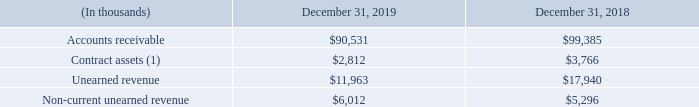Revenue allocated to remaining performance obligations represents contract revenues that have not yet been recognized for contracts with a duration greater than one year. As of December 31, 2019, we did not have any significant performance obligations related to customer contracts that had an original expected duration of one year or more, other than maintenance services, which are satisfied over time. As a practical expedient, for certain contracts recognize revenue equal to the amounts we are entitled to invoice which correspond to the value of completed performance obligations to date. The amount related to these performance obligations was $13.3 million as of December 31, 2018. The amount related to these performance obligations was $13.6 million as of December 31, 2019, and the Company expects to recognize 64% of such revenue over the next 12 months with the remainder thereafter.
The following table provides information about accounts receivables, contract assets and unearned revenue from contracts with customers:
(1) Included in other receivables on the Consolidated Balance Sheets
Of the outstanding unearned revenue balance as of December 31, 2018, $12.7 million was recognized as revenue during the year ended December 31, 2019.
How much of the outstanding unearned revenue balance as of December 31, 2018 was recognized as revenue in 2019? $12.7 million. What was the amount of Accounts Receivable in 2019?
Answer scale should be: thousand. $90,531. What was the amount of Unearned revenue in 2019?
Answer scale should be: thousand. $11,963. What was the change in contract assets between 2018 and 2019?
Answer scale should be: thousand. $2,812-$3,766
Answer: -954. What was the change in non-current unearned revenue between 2018 and 2019?
Answer scale should be: thousand. $6,012-$5,296
Answer: 716. What was the percentage change in unearned revenue between 2018 and 2019?
Answer scale should be: percent. ($11,963-$17,940)/$17,940
Answer: -33.32. 